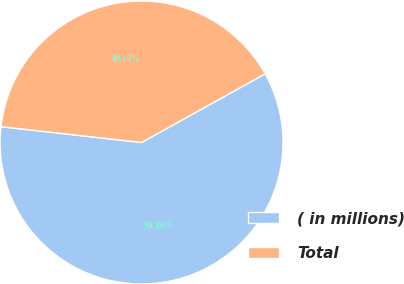Convert chart to OTSL. <chart><loc_0><loc_0><loc_500><loc_500><pie_chart><fcel>( in millions)<fcel>Total<nl><fcel>59.86%<fcel>40.14%<nl></chart> 